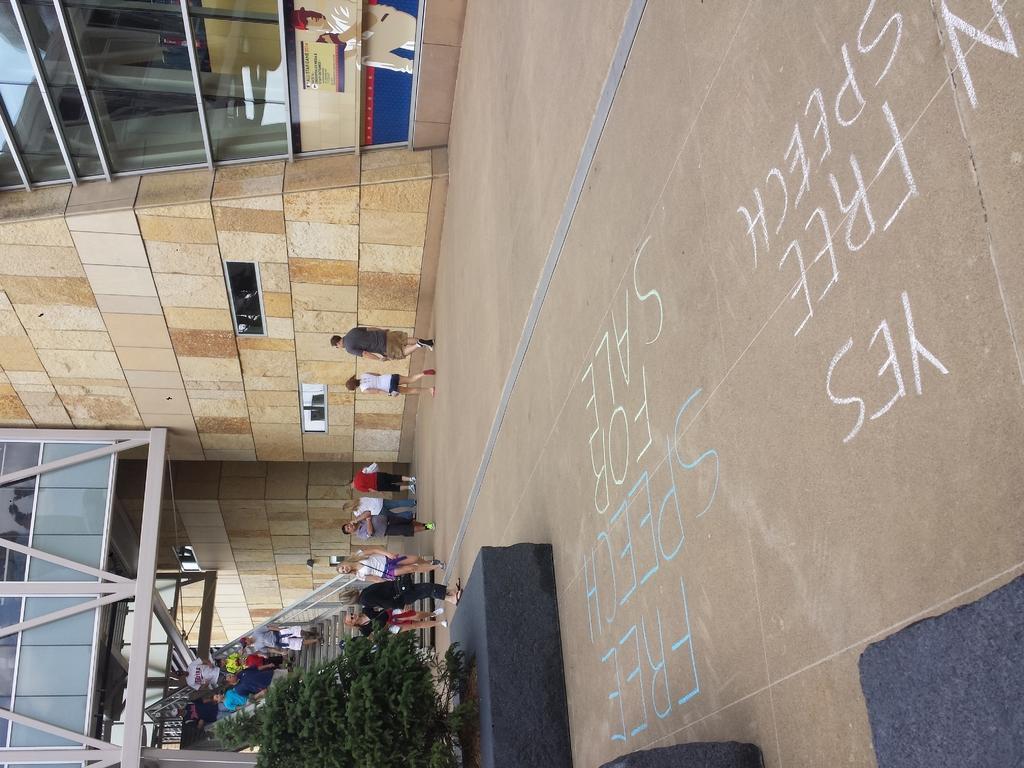Describe this image in one or two sentences. At the bottom of this image, there are plants. Beside these plants, there are some texts written on the road and there are persons walking on the road. In the background, there are buildings, there are persons on the steps and there is a bridge. 